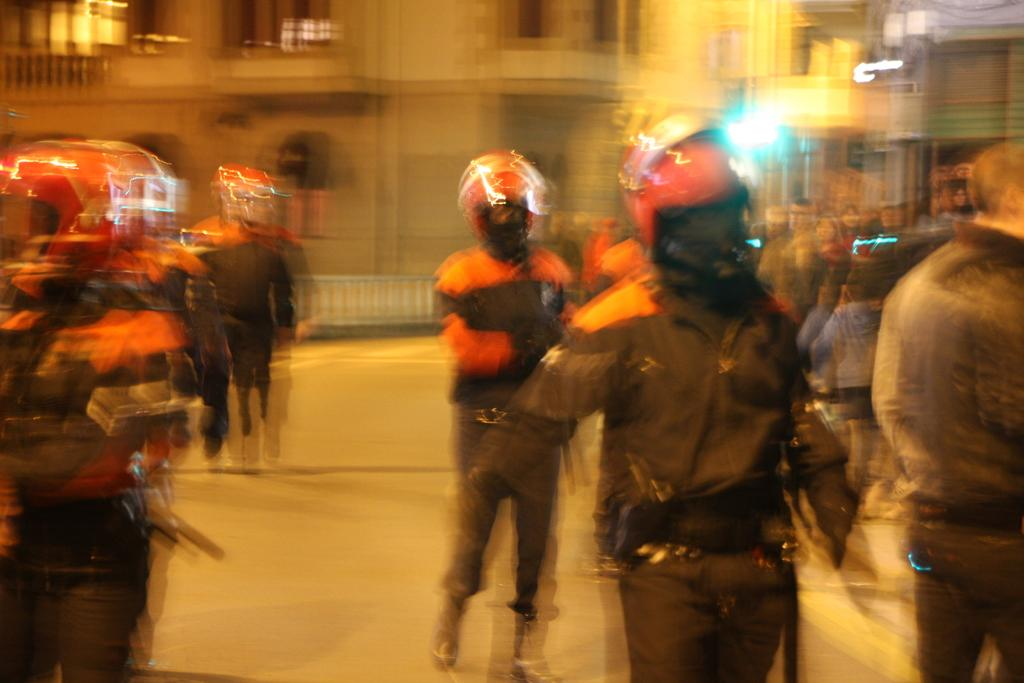What is happening on the road in the image? There are people on the road in the image. What are the people wearing on their heads? The people are wearing helmets. What can be seen in the background of the image? There is a building in the background of the image. How would you describe the overall clarity of the image? The entire image is blurred. What type of wave can be seen crashing on the shore in the image? There is no wave or shore present in the image; it features people on the road wearing helmets. Can you tell me what toy the person in the image is holding? There is no toy visible in the image; the people are wearing helmets and there are no other objects mentioned. 